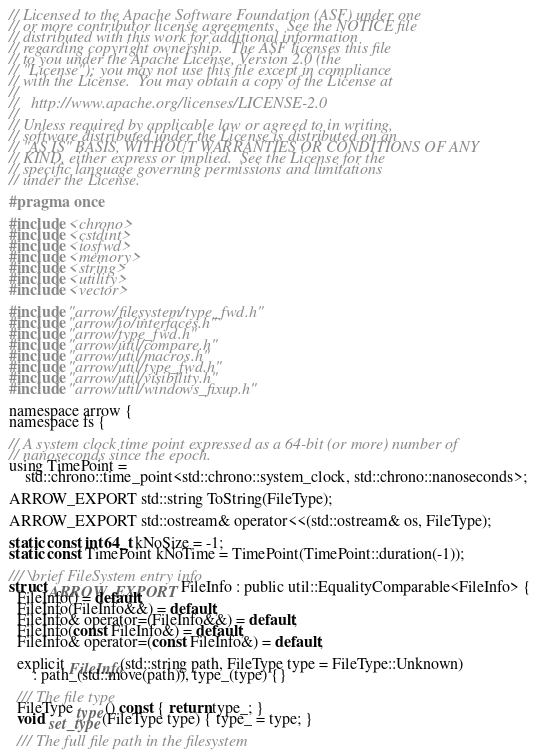<code> <loc_0><loc_0><loc_500><loc_500><_C_>// Licensed to the Apache Software Foundation (ASF) under one
// or more contributor license agreements.  See the NOTICE file
// distributed with this work for additional information
// regarding copyright ownership.  The ASF licenses this file
// to you under the Apache License, Version 2.0 (the
// "License"); you may not use this file except in compliance
// with the License.  You may obtain a copy of the License at
//
//   http://www.apache.org/licenses/LICENSE-2.0
//
// Unless required by applicable law or agreed to in writing,
// software distributed under the License is distributed on an
// "AS IS" BASIS, WITHOUT WARRANTIES OR CONDITIONS OF ANY
// KIND, either express or implied.  See the License for the
// specific language governing permissions and limitations
// under the License.

#pragma once

#include <chrono>
#include <cstdint>
#include <iosfwd>
#include <memory>
#include <string>
#include <utility>
#include <vector>

#include "arrow/filesystem/type_fwd.h"
#include "arrow/io/interfaces.h"
#include "arrow/type_fwd.h"
#include "arrow/util/compare.h"
#include "arrow/util/macros.h"
#include "arrow/util/type_fwd.h"
#include "arrow/util/visibility.h"
#include "arrow/util/windows_fixup.h"

namespace arrow {
namespace fs {

// A system clock time point expressed as a 64-bit (or more) number of
// nanoseconds since the epoch.
using TimePoint =
    std::chrono::time_point<std::chrono::system_clock, std::chrono::nanoseconds>;

ARROW_EXPORT std::string ToString(FileType);

ARROW_EXPORT std::ostream& operator<<(std::ostream& os, FileType);

static const int64_t kNoSize = -1;
static const TimePoint kNoTime = TimePoint(TimePoint::duration(-1));

/// \brief FileSystem entry info
struct ARROW_EXPORT FileInfo : public util::EqualityComparable<FileInfo> {
  FileInfo() = default;
  FileInfo(FileInfo&&) = default;
  FileInfo& operator=(FileInfo&&) = default;
  FileInfo(const FileInfo&) = default;
  FileInfo& operator=(const FileInfo&) = default;

  explicit FileInfo(std::string path, FileType type = FileType::Unknown)
      : path_(std::move(path)), type_(type) {}

  /// The file type
  FileType type() const { return type_; }
  void set_type(FileType type) { type_ = type; }

  /// The full file path in the filesystem</code> 